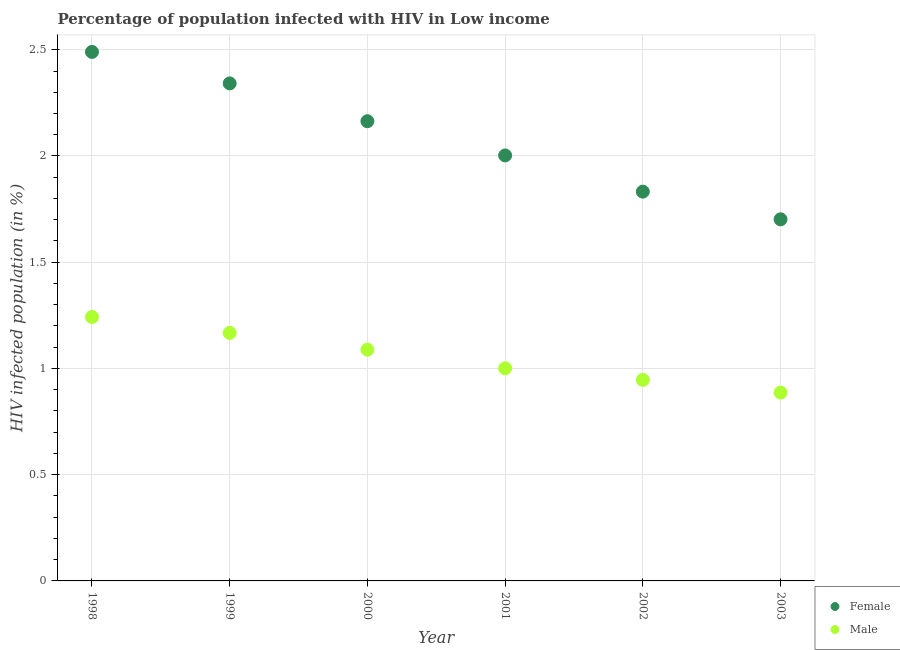What is the percentage of females who are infected with hiv in 2003?
Your response must be concise. 1.7. Across all years, what is the maximum percentage of females who are infected with hiv?
Provide a short and direct response. 2.49. Across all years, what is the minimum percentage of females who are infected with hiv?
Your answer should be very brief. 1.7. In which year was the percentage of females who are infected with hiv minimum?
Keep it short and to the point. 2003. What is the total percentage of females who are infected with hiv in the graph?
Give a very brief answer. 12.53. What is the difference between the percentage of males who are infected with hiv in 1998 and that in 2002?
Provide a succinct answer. 0.3. What is the difference between the percentage of females who are infected with hiv in 2002 and the percentage of males who are infected with hiv in 2000?
Provide a short and direct response. 0.74. What is the average percentage of males who are infected with hiv per year?
Keep it short and to the point. 1.06. In the year 2002, what is the difference between the percentage of males who are infected with hiv and percentage of females who are infected with hiv?
Keep it short and to the point. -0.89. What is the ratio of the percentage of males who are infected with hiv in 1998 to that in 1999?
Your response must be concise. 1.06. Is the percentage of females who are infected with hiv in 2000 less than that in 2001?
Keep it short and to the point. No. What is the difference between the highest and the second highest percentage of males who are infected with hiv?
Keep it short and to the point. 0.07. What is the difference between the highest and the lowest percentage of females who are infected with hiv?
Give a very brief answer. 0.79. What is the difference between two consecutive major ticks on the Y-axis?
Your answer should be very brief. 0.5. Are the values on the major ticks of Y-axis written in scientific E-notation?
Make the answer very short. No. Does the graph contain any zero values?
Provide a short and direct response. No. Where does the legend appear in the graph?
Offer a very short reply. Bottom right. How many legend labels are there?
Provide a succinct answer. 2. What is the title of the graph?
Keep it short and to the point. Percentage of population infected with HIV in Low income. Does "International Visitors" appear as one of the legend labels in the graph?
Your answer should be very brief. No. What is the label or title of the Y-axis?
Give a very brief answer. HIV infected population (in %). What is the HIV infected population (in %) of Female in 1998?
Your response must be concise. 2.49. What is the HIV infected population (in %) of Male in 1998?
Provide a succinct answer. 1.24. What is the HIV infected population (in %) of Female in 1999?
Provide a succinct answer. 2.34. What is the HIV infected population (in %) of Male in 1999?
Ensure brevity in your answer.  1.17. What is the HIV infected population (in %) of Female in 2000?
Ensure brevity in your answer.  2.16. What is the HIV infected population (in %) of Male in 2000?
Ensure brevity in your answer.  1.09. What is the HIV infected population (in %) of Female in 2001?
Provide a succinct answer. 2. What is the HIV infected population (in %) in Male in 2001?
Offer a terse response. 1. What is the HIV infected population (in %) of Female in 2002?
Make the answer very short. 1.83. What is the HIV infected population (in %) of Male in 2002?
Offer a terse response. 0.95. What is the HIV infected population (in %) in Female in 2003?
Provide a short and direct response. 1.7. What is the HIV infected population (in %) of Male in 2003?
Your answer should be compact. 0.89. Across all years, what is the maximum HIV infected population (in %) of Female?
Your answer should be very brief. 2.49. Across all years, what is the maximum HIV infected population (in %) of Male?
Provide a succinct answer. 1.24. Across all years, what is the minimum HIV infected population (in %) of Female?
Keep it short and to the point. 1.7. Across all years, what is the minimum HIV infected population (in %) in Male?
Your answer should be compact. 0.89. What is the total HIV infected population (in %) in Female in the graph?
Provide a short and direct response. 12.53. What is the total HIV infected population (in %) in Male in the graph?
Keep it short and to the point. 6.33. What is the difference between the HIV infected population (in %) in Female in 1998 and that in 1999?
Ensure brevity in your answer.  0.15. What is the difference between the HIV infected population (in %) in Male in 1998 and that in 1999?
Offer a very short reply. 0.07. What is the difference between the HIV infected population (in %) of Female in 1998 and that in 2000?
Keep it short and to the point. 0.33. What is the difference between the HIV infected population (in %) of Male in 1998 and that in 2000?
Keep it short and to the point. 0.15. What is the difference between the HIV infected population (in %) of Female in 1998 and that in 2001?
Your answer should be compact. 0.49. What is the difference between the HIV infected population (in %) of Male in 1998 and that in 2001?
Give a very brief answer. 0.24. What is the difference between the HIV infected population (in %) of Female in 1998 and that in 2002?
Give a very brief answer. 0.66. What is the difference between the HIV infected population (in %) of Male in 1998 and that in 2002?
Keep it short and to the point. 0.3. What is the difference between the HIV infected population (in %) of Female in 1998 and that in 2003?
Offer a terse response. 0.79. What is the difference between the HIV infected population (in %) in Male in 1998 and that in 2003?
Provide a short and direct response. 0.36. What is the difference between the HIV infected population (in %) of Female in 1999 and that in 2000?
Your response must be concise. 0.18. What is the difference between the HIV infected population (in %) in Male in 1999 and that in 2000?
Ensure brevity in your answer.  0.08. What is the difference between the HIV infected population (in %) of Female in 1999 and that in 2001?
Your answer should be very brief. 0.34. What is the difference between the HIV infected population (in %) in Male in 1999 and that in 2001?
Provide a short and direct response. 0.17. What is the difference between the HIV infected population (in %) of Female in 1999 and that in 2002?
Your response must be concise. 0.51. What is the difference between the HIV infected population (in %) of Male in 1999 and that in 2002?
Provide a short and direct response. 0.22. What is the difference between the HIV infected population (in %) of Female in 1999 and that in 2003?
Make the answer very short. 0.64. What is the difference between the HIV infected population (in %) of Male in 1999 and that in 2003?
Provide a short and direct response. 0.28. What is the difference between the HIV infected population (in %) in Female in 2000 and that in 2001?
Give a very brief answer. 0.16. What is the difference between the HIV infected population (in %) of Male in 2000 and that in 2001?
Your response must be concise. 0.09. What is the difference between the HIV infected population (in %) of Female in 2000 and that in 2002?
Ensure brevity in your answer.  0.33. What is the difference between the HIV infected population (in %) in Male in 2000 and that in 2002?
Make the answer very short. 0.14. What is the difference between the HIV infected population (in %) of Female in 2000 and that in 2003?
Your answer should be compact. 0.46. What is the difference between the HIV infected population (in %) in Male in 2000 and that in 2003?
Give a very brief answer. 0.2. What is the difference between the HIV infected population (in %) of Female in 2001 and that in 2002?
Ensure brevity in your answer.  0.17. What is the difference between the HIV infected population (in %) in Male in 2001 and that in 2002?
Make the answer very short. 0.05. What is the difference between the HIV infected population (in %) of Female in 2001 and that in 2003?
Provide a succinct answer. 0.3. What is the difference between the HIV infected population (in %) in Male in 2001 and that in 2003?
Your response must be concise. 0.11. What is the difference between the HIV infected population (in %) in Female in 2002 and that in 2003?
Make the answer very short. 0.13. What is the difference between the HIV infected population (in %) in Male in 2002 and that in 2003?
Your answer should be very brief. 0.06. What is the difference between the HIV infected population (in %) of Female in 1998 and the HIV infected population (in %) of Male in 1999?
Provide a succinct answer. 1.32. What is the difference between the HIV infected population (in %) in Female in 1998 and the HIV infected population (in %) in Male in 2000?
Ensure brevity in your answer.  1.4. What is the difference between the HIV infected population (in %) of Female in 1998 and the HIV infected population (in %) of Male in 2001?
Keep it short and to the point. 1.49. What is the difference between the HIV infected population (in %) in Female in 1998 and the HIV infected population (in %) in Male in 2002?
Offer a very short reply. 1.54. What is the difference between the HIV infected population (in %) in Female in 1998 and the HIV infected population (in %) in Male in 2003?
Give a very brief answer. 1.6. What is the difference between the HIV infected population (in %) of Female in 1999 and the HIV infected population (in %) of Male in 2000?
Keep it short and to the point. 1.25. What is the difference between the HIV infected population (in %) of Female in 1999 and the HIV infected population (in %) of Male in 2001?
Your answer should be very brief. 1.34. What is the difference between the HIV infected population (in %) of Female in 1999 and the HIV infected population (in %) of Male in 2002?
Keep it short and to the point. 1.4. What is the difference between the HIV infected population (in %) in Female in 1999 and the HIV infected population (in %) in Male in 2003?
Keep it short and to the point. 1.46. What is the difference between the HIV infected population (in %) in Female in 2000 and the HIV infected population (in %) in Male in 2001?
Provide a succinct answer. 1.16. What is the difference between the HIV infected population (in %) of Female in 2000 and the HIV infected population (in %) of Male in 2002?
Provide a short and direct response. 1.22. What is the difference between the HIV infected population (in %) of Female in 2000 and the HIV infected population (in %) of Male in 2003?
Make the answer very short. 1.28. What is the difference between the HIV infected population (in %) in Female in 2001 and the HIV infected population (in %) in Male in 2002?
Your response must be concise. 1.06. What is the difference between the HIV infected population (in %) of Female in 2001 and the HIV infected population (in %) of Male in 2003?
Your response must be concise. 1.12. What is the difference between the HIV infected population (in %) of Female in 2002 and the HIV infected population (in %) of Male in 2003?
Keep it short and to the point. 0.95. What is the average HIV infected population (in %) in Female per year?
Your answer should be compact. 2.09. What is the average HIV infected population (in %) in Male per year?
Give a very brief answer. 1.06. In the year 1998, what is the difference between the HIV infected population (in %) in Female and HIV infected population (in %) in Male?
Offer a terse response. 1.25. In the year 1999, what is the difference between the HIV infected population (in %) of Female and HIV infected population (in %) of Male?
Your answer should be compact. 1.17. In the year 2000, what is the difference between the HIV infected population (in %) in Female and HIV infected population (in %) in Male?
Offer a terse response. 1.08. In the year 2002, what is the difference between the HIV infected population (in %) in Female and HIV infected population (in %) in Male?
Your answer should be compact. 0.89. In the year 2003, what is the difference between the HIV infected population (in %) in Female and HIV infected population (in %) in Male?
Your answer should be very brief. 0.82. What is the ratio of the HIV infected population (in %) in Female in 1998 to that in 1999?
Provide a short and direct response. 1.06. What is the ratio of the HIV infected population (in %) of Male in 1998 to that in 1999?
Provide a succinct answer. 1.06. What is the ratio of the HIV infected population (in %) of Female in 1998 to that in 2000?
Your answer should be compact. 1.15. What is the ratio of the HIV infected population (in %) of Male in 1998 to that in 2000?
Keep it short and to the point. 1.14. What is the ratio of the HIV infected population (in %) in Female in 1998 to that in 2001?
Make the answer very short. 1.24. What is the ratio of the HIV infected population (in %) in Male in 1998 to that in 2001?
Your answer should be very brief. 1.24. What is the ratio of the HIV infected population (in %) in Female in 1998 to that in 2002?
Your answer should be compact. 1.36. What is the ratio of the HIV infected population (in %) in Male in 1998 to that in 2002?
Provide a succinct answer. 1.31. What is the ratio of the HIV infected population (in %) in Female in 1998 to that in 2003?
Give a very brief answer. 1.46. What is the ratio of the HIV infected population (in %) in Male in 1998 to that in 2003?
Offer a very short reply. 1.4. What is the ratio of the HIV infected population (in %) in Female in 1999 to that in 2000?
Offer a very short reply. 1.08. What is the ratio of the HIV infected population (in %) of Male in 1999 to that in 2000?
Provide a short and direct response. 1.07. What is the ratio of the HIV infected population (in %) in Female in 1999 to that in 2001?
Ensure brevity in your answer.  1.17. What is the ratio of the HIV infected population (in %) in Female in 1999 to that in 2002?
Ensure brevity in your answer.  1.28. What is the ratio of the HIV infected population (in %) in Male in 1999 to that in 2002?
Keep it short and to the point. 1.23. What is the ratio of the HIV infected population (in %) in Female in 1999 to that in 2003?
Your response must be concise. 1.38. What is the ratio of the HIV infected population (in %) of Male in 1999 to that in 2003?
Offer a terse response. 1.32. What is the ratio of the HIV infected population (in %) of Female in 2000 to that in 2001?
Provide a short and direct response. 1.08. What is the ratio of the HIV infected population (in %) of Male in 2000 to that in 2001?
Your answer should be compact. 1.09. What is the ratio of the HIV infected population (in %) of Female in 2000 to that in 2002?
Provide a short and direct response. 1.18. What is the ratio of the HIV infected population (in %) in Male in 2000 to that in 2002?
Your answer should be compact. 1.15. What is the ratio of the HIV infected population (in %) in Female in 2000 to that in 2003?
Make the answer very short. 1.27. What is the ratio of the HIV infected population (in %) of Male in 2000 to that in 2003?
Your response must be concise. 1.23. What is the ratio of the HIV infected population (in %) of Female in 2001 to that in 2002?
Provide a succinct answer. 1.09. What is the ratio of the HIV infected population (in %) of Male in 2001 to that in 2002?
Provide a short and direct response. 1.06. What is the ratio of the HIV infected population (in %) in Female in 2001 to that in 2003?
Keep it short and to the point. 1.18. What is the ratio of the HIV infected population (in %) in Male in 2001 to that in 2003?
Make the answer very short. 1.13. What is the ratio of the HIV infected population (in %) in Female in 2002 to that in 2003?
Offer a very short reply. 1.08. What is the ratio of the HIV infected population (in %) of Male in 2002 to that in 2003?
Your response must be concise. 1.07. What is the difference between the highest and the second highest HIV infected population (in %) in Female?
Your answer should be compact. 0.15. What is the difference between the highest and the second highest HIV infected population (in %) of Male?
Give a very brief answer. 0.07. What is the difference between the highest and the lowest HIV infected population (in %) in Female?
Give a very brief answer. 0.79. What is the difference between the highest and the lowest HIV infected population (in %) in Male?
Make the answer very short. 0.36. 